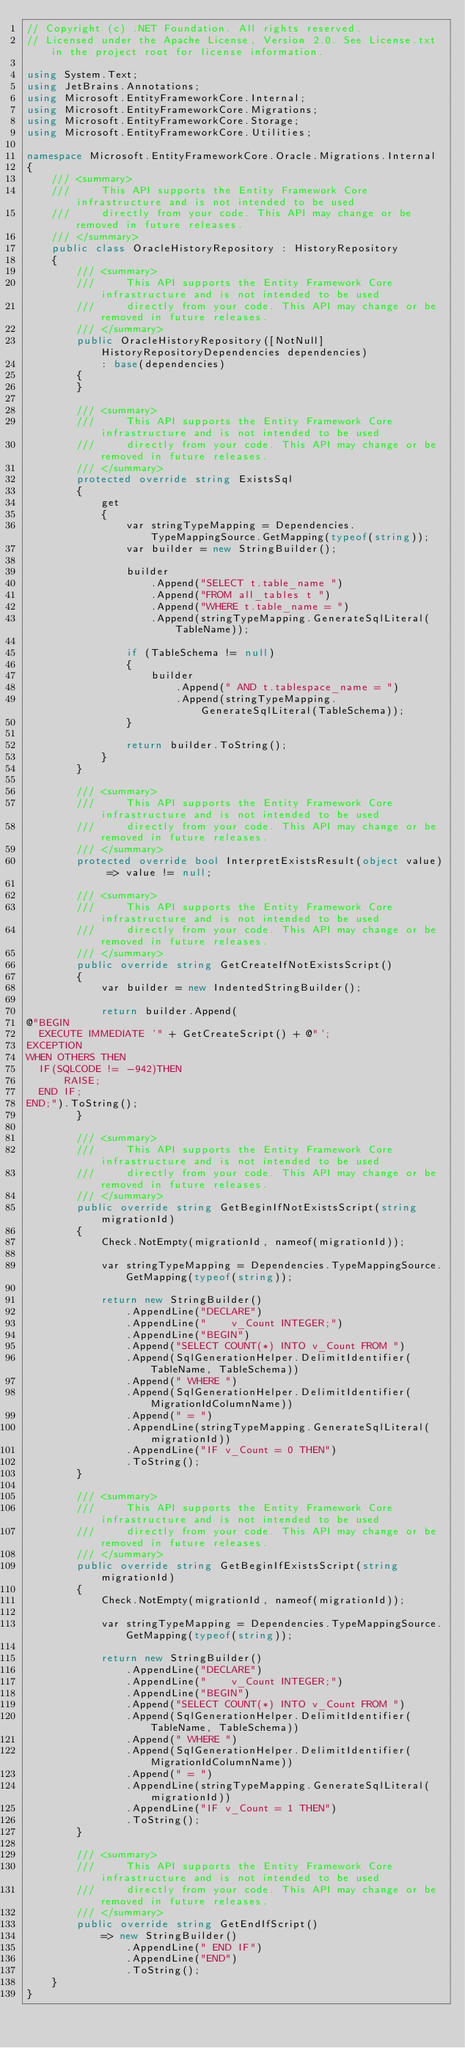Convert code to text. <code><loc_0><loc_0><loc_500><loc_500><_C#_>// Copyright (c) .NET Foundation. All rights reserved.
// Licensed under the Apache License, Version 2.0. See License.txt in the project root for license information.

using System.Text;
using JetBrains.Annotations;
using Microsoft.EntityFrameworkCore.Internal;
using Microsoft.EntityFrameworkCore.Migrations;
using Microsoft.EntityFrameworkCore.Storage;
using Microsoft.EntityFrameworkCore.Utilities;

namespace Microsoft.EntityFrameworkCore.Oracle.Migrations.Internal
{
    /// <summary>
    ///     This API supports the Entity Framework Core infrastructure and is not intended to be used
    ///     directly from your code. This API may change or be removed in future releases.
    /// </summary>
    public class OracleHistoryRepository : HistoryRepository
    {
        /// <summary>
        ///     This API supports the Entity Framework Core infrastructure and is not intended to be used
        ///     directly from your code. This API may change or be removed in future releases.
        /// </summary>
        public OracleHistoryRepository([NotNull] HistoryRepositoryDependencies dependencies)
            : base(dependencies)
        {
        }

        /// <summary>
        ///     This API supports the Entity Framework Core infrastructure and is not intended to be used
        ///     directly from your code. This API may change or be removed in future releases.
        /// </summary>
        protected override string ExistsSql
        {
            get
            {
                var stringTypeMapping = Dependencies.TypeMappingSource.GetMapping(typeof(string));
                var builder = new StringBuilder();

                builder
                    .Append("SELECT t.table_name ")
                    .Append("FROM all_tables t ")
                    .Append("WHERE t.table_name = ")
                    .Append(stringTypeMapping.GenerateSqlLiteral(TableName));

                if (TableSchema != null)
                {
                    builder
                        .Append(" AND t.tablespace_name = ")
                        .Append(stringTypeMapping.GenerateSqlLiteral(TableSchema));
                }

                return builder.ToString();
            }
        }

        /// <summary>
        ///     This API supports the Entity Framework Core infrastructure and is not intended to be used
        ///     directly from your code. This API may change or be removed in future releases.
        /// </summary>
        protected override bool InterpretExistsResult(object value) => value != null;

        /// <summary>
        ///     This API supports the Entity Framework Core infrastructure and is not intended to be used
        ///     directly from your code. This API may change or be removed in future releases.
        /// </summary>
        public override string GetCreateIfNotExistsScript()
        {
            var builder = new IndentedStringBuilder();

            return builder.Append(
@"BEGIN
  EXECUTE IMMEDIATE '" + GetCreateScript() + @"';
EXCEPTION
WHEN OTHERS THEN
  IF(SQLCODE != -942)THEN
      RAISE;
  END IF;
END;").ToString();
        }

        /// <summary>
        ///     This API supports the Entity Framework Core infrastructure and is not intended to be used
        ///     directly from your code. This API may change or be removed in future releases.
        /// </summary>
        public override string GetBeginIfNotExistsScript(string migrationId)
        {
            Check.NotEmpty(migrationId, nameof(migrationId));

            var stringTypeMapping = Dependencies.TypeMappingSource.GetMapping(typeof(string));

            return new StringBuilder()
                .AppendLine("DECLARE")
                .AppendLine("    v_Count INTEGER;")
                .AppendLine("BEGIN")
                .Append("SELECT COUNT(*) INTO v_Count FROM ")
                .Append(SqlGenerationHelper.DelimitIdentifier(TableName, TableSchema))
                .Append(" WHERE ")
                .Append(SqlGenerationHelper.DelimitIdentifier(MigrationIdColumnName))
                .Append(" = ")
                .AppendLine(stringTypeMapping.GenerateSqlLiteral(migrationId))
                .AppendLine("IF v_Count = 0 THEN")
                .ToString();
        }

        /// <summary>
        ///     This API supports the Entity Framework Core infrastructure and is not intended to be used
        ///     directly from your code. This API may change or be removed in future releases.
        /// </summary>
        public override string GetBeginIfExistsScript(string migrationId)
        {
            Check.NotEmpty(migrationId, nameof(migrationId));

            var stringTypeMapping = Dependencies.TypeMappingSource.GetMapping(typeof(string));

            return new StringBuilder()
                .AppendLine("DECLARE")
                .AppendLine("    v_Count INTEGER;")
                .AppendLine("BEGIN")
                .Append("SELECT COUNT(*) INTO v_Count FROM ")
                .Append(SqlGenerationHelper.DelimitIdentifier(TableName, TableSchema))
                .Append(" WHERE ")
                .Append(SqlGenerationHelper.DelimitIdentifier(MigrationIdColumnName))
                .Append(" = ")
                .AppendLine(stringTypeMapping.GenerateSqlLiteral(migrationId))
                .AppendLine("IF v_Count = 1 THEN")
                .ToString();
        }

        /// <summary>
        ///     This API supports the Entity Framework Core infrastructure and is not intended to be used
        ///     directly from your code. This API may change or be removed in future releases.
        /// </summary>
        public override string GetEndIfScript()
            => new StringBuilder()
                .AppendLine(" END IF")
                .AppendLine("END")
                .ToString();
    }
}
</code> 